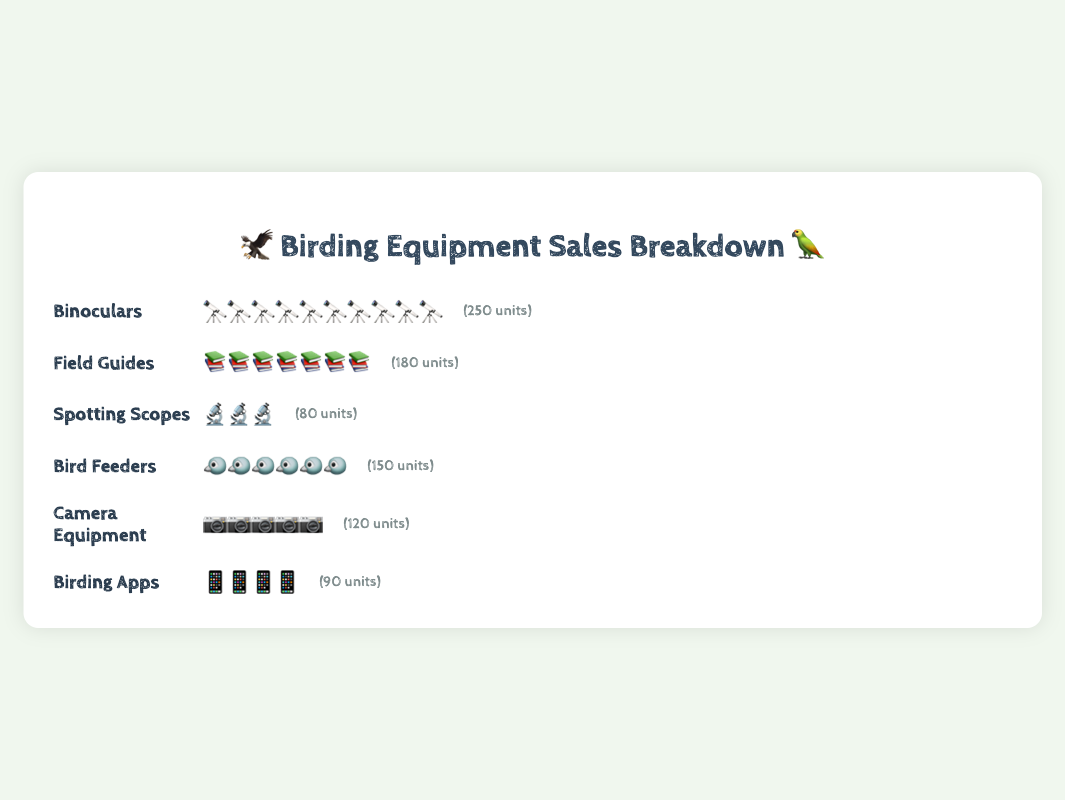What category has the highest sales? The figure shows Binoculars with the most icons, representing 250 units sold.
Answer: Binoculars Which category sold the least amount of equipment? Spotting Scopes have the fewest icons, representing 80 units sold.
Answer: Spotting Scopes How many more units did Camera Equipment sell compared to Birding Apps? Camera Equipment sold 120 units, and Birding Apps sold 90 units. The difference is 120 - 90 = 30 units.
Answer: 30 units What is the total number of units sold across all categories? Sum of all units sold: 250 (Binoculars) + 180 (Field Guides) + 80 (Spotting Scopes) + 150 (Bird Feeders) + 120 (Camera Equipment) + 90 (Birding Apps) = 870 units.
Answer: 870 units Which category sold 150 units? Bird Feeders have icons representing 150 units sold.
Answer: Bird Feeders How many categories sold more than 100 units? The categories with more than 100 units are Binoculars (250), Field Guides (180), Bird Feeders (150), and Camera Equipment (120). That's four categories.
Answer: 4 categories Compare the sales of Field Guides to Birding Apps. Which one sold more and by how much? Field Guides sold 180 units, and Birding Apps sold 90 units. Field Guides sold more by 180 - 90 = 90 units.
Answer: Field Guides by 90 units How many icons represent each unit for the Camera Equipment category? Camera Equipment sold 120 units and has 10 icons. Each icon represents 120 / 10 = 12 units.
Answer: 12 units per icon What percentage of total sales do Binoculars represent? Binoculars sold 250 units out of a total of 870 units. The percentage is (250 / 870) * 100 ≈ 28.74%.
Answer: ~28.74% If the sales for Spotting Scopes doubled, how would that compare to the current sales of Camera Equipment? Spotting Scopes currently sold 80 units. If doubled, that would be 80 * 2 = 160 units, which is more than the 120 units sold by Camera Equipment.
Answer: Spotting Scopes would sell 160 units, which is more 